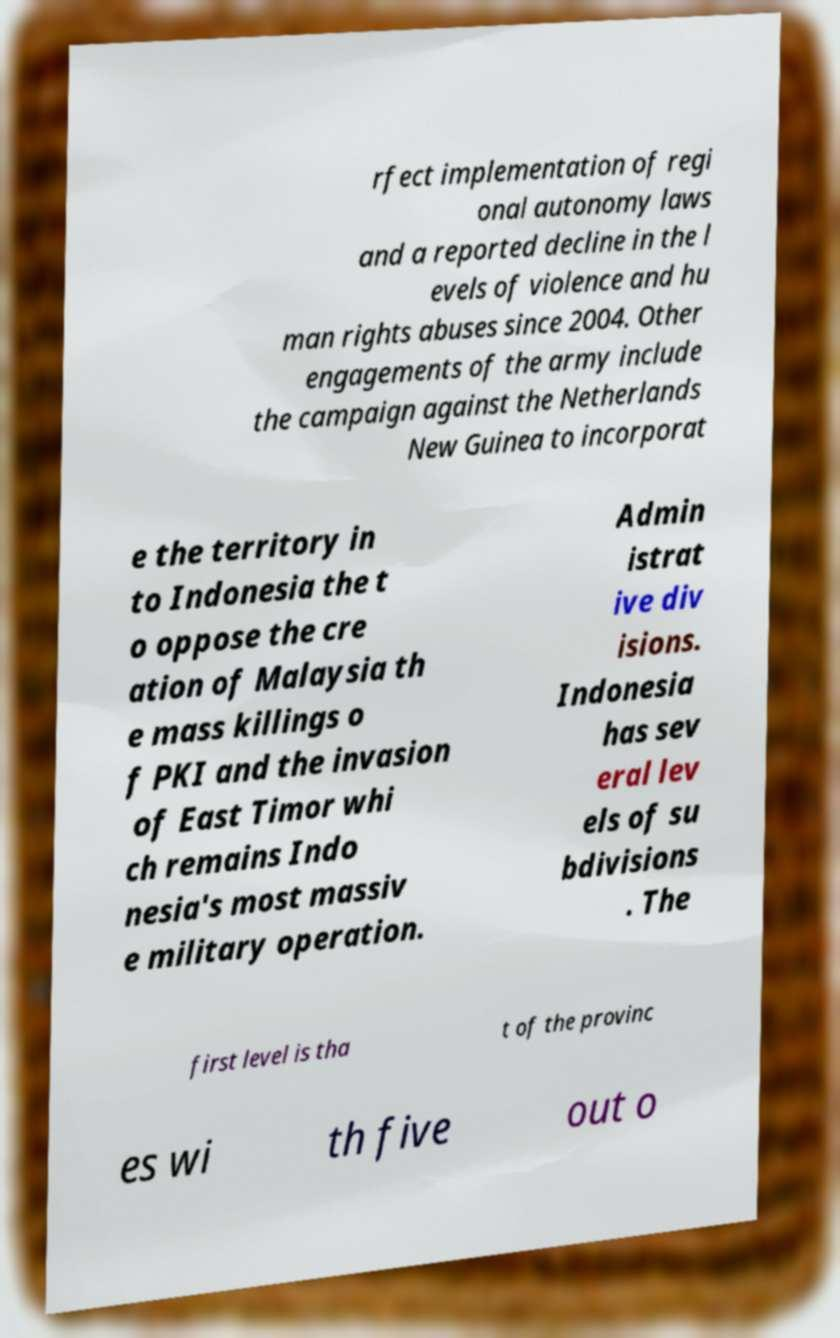What messages or text are displayed in this image? I need them in a readable, typed format. rfect implementation of regi onal autonomy laws and a reported decline in the l evels of violence and hu man rights abuses since 2004. Other engagements of the army include the campaign against the Netherlands New Guinea to incorporat e the territory in to Indonesia the t o oppose the cre ation of Malaysia th e mass killings o f PKI and the invasion of East Timor whi ch remains Indo nesia's most massiv e military operation. Admin istrat ive div isions. Indonesia has sev eral lev els of su bdivisions . The first level is tha t of the provinc es wi th five out o 